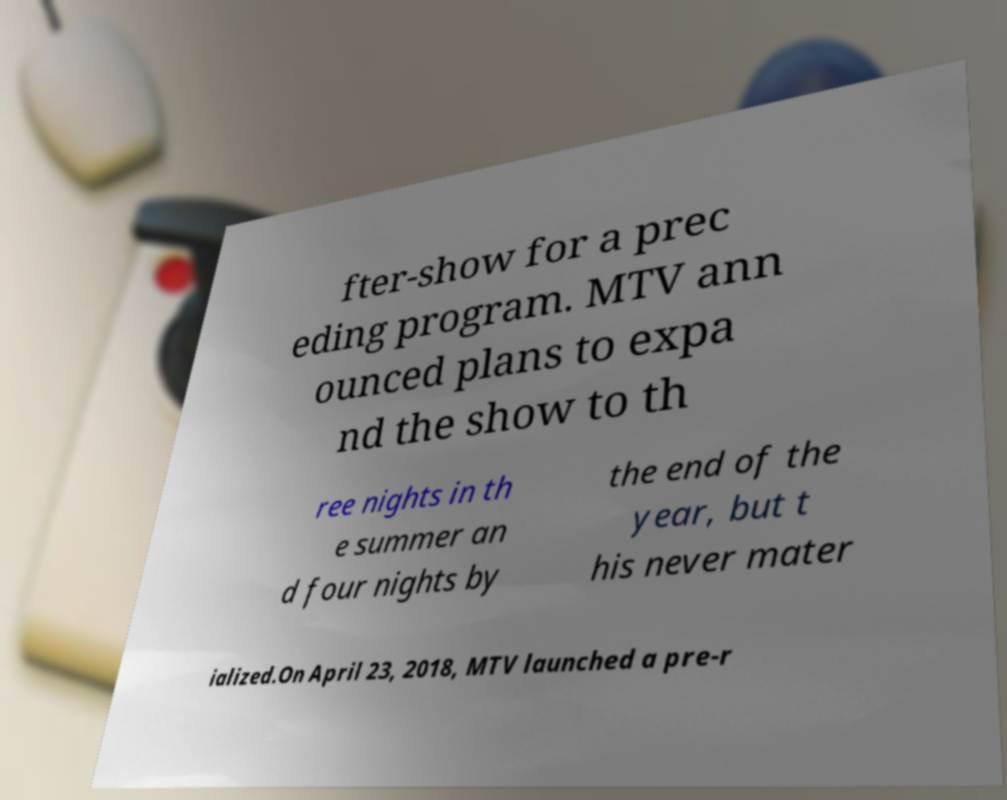What messages or text are displayed in this image? I need them in a readable, typed format. fter-show for a prec eding program. MTV ann ounced plans to expa nd the show to th ree nights in th e summer an d four nights by the end of the year, but t his never mater ialized.On April 23, 2018, MTV launched a pre-r 